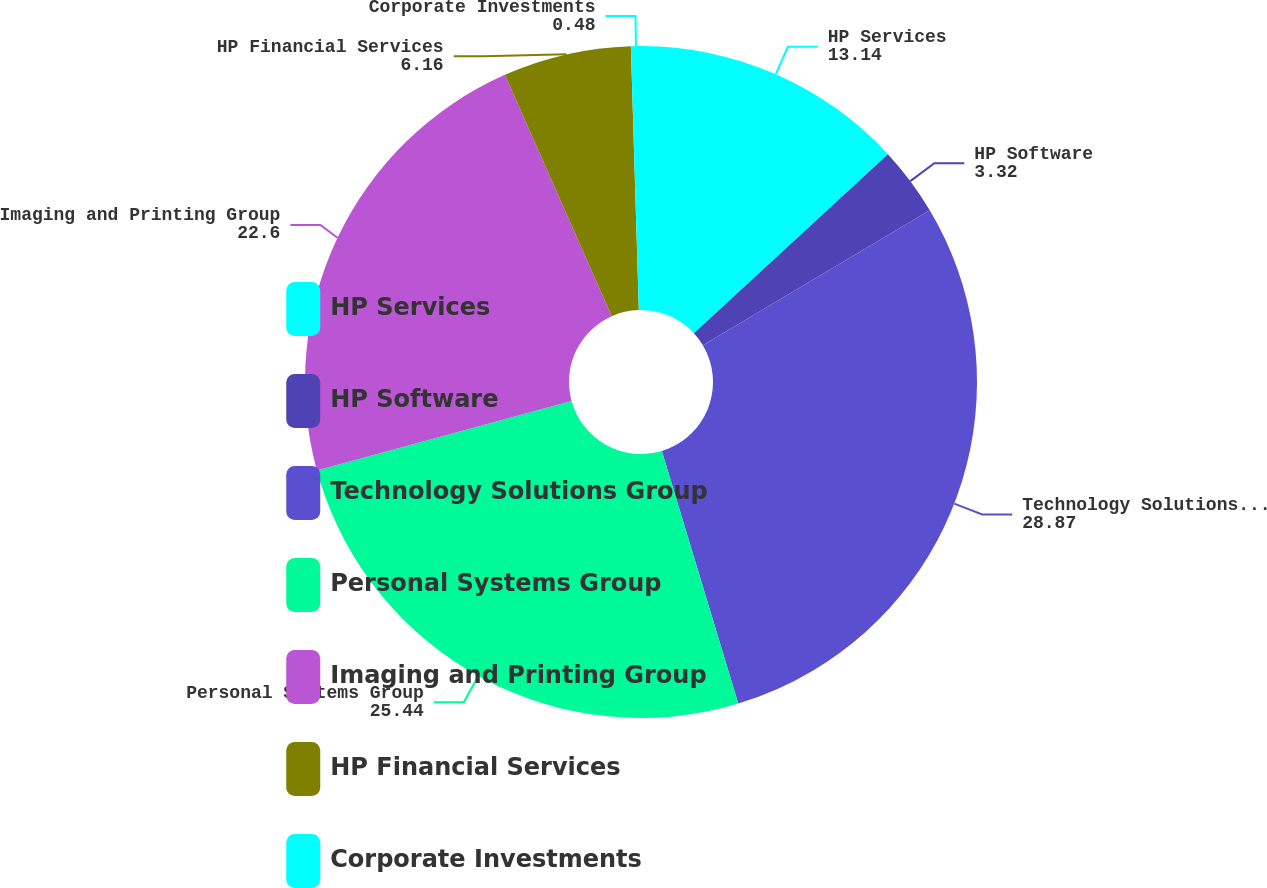Convert chart to OTSL. <chart><loc_0><loc_0><loc_500><loc_500><pie_chart><fcel>HP Services<fcel>HP Software<fcel>Technology Solutions Group<fcel>Personal Systems Group<fcel>Imaging and Printing Group<fcel>HP Financial Services<fcel>Corporate Investments<nl><fcel>13.14%<fcel>3.32%<fcel>28.87%<fcel>25.44%<fcel>22.6%<fcel>6.16%<fcel>0.48%<nl></chart> 